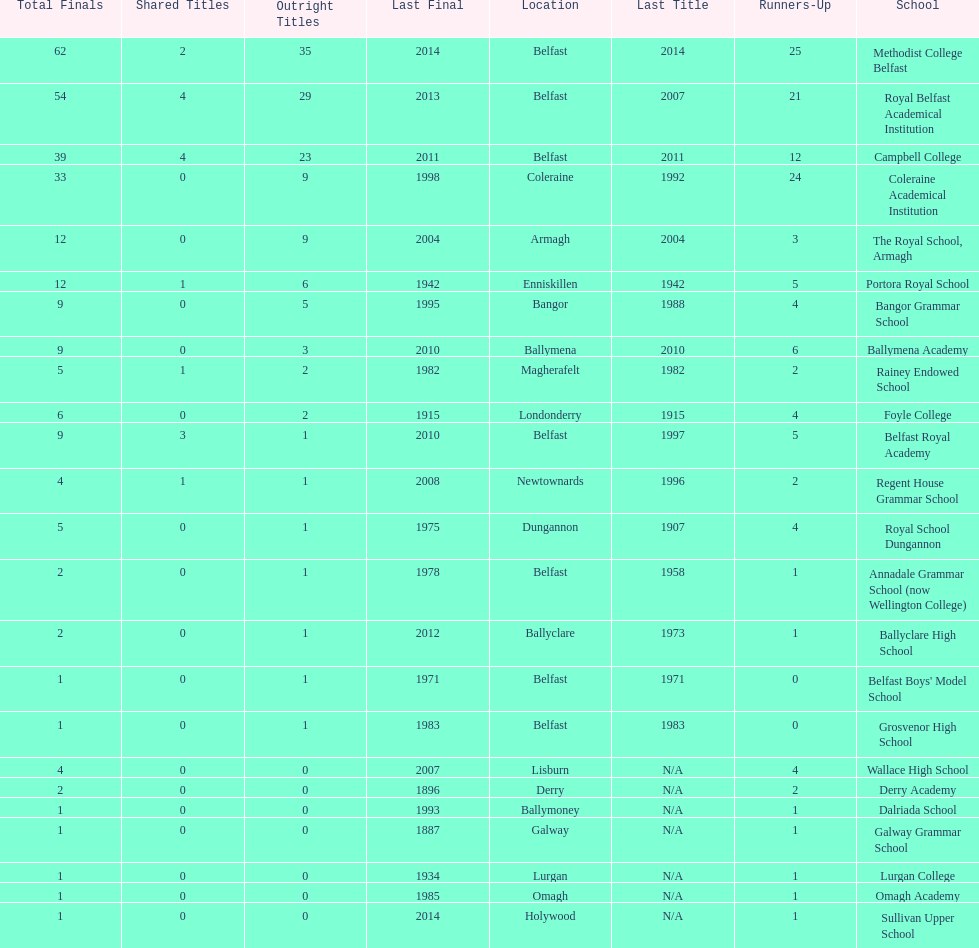Which two schools each had twelve total finals? The Royal School, Armagh, Portora Royal School. 